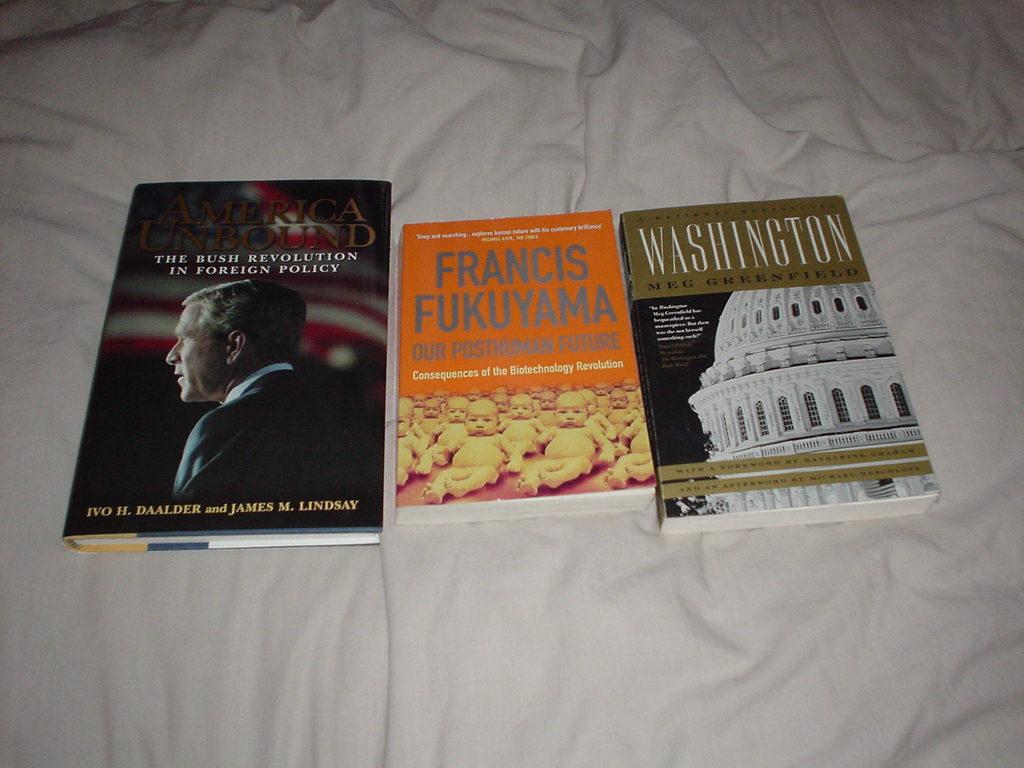Who wrote the orange book?
Give a very brief answer. Francis fukuyama. 